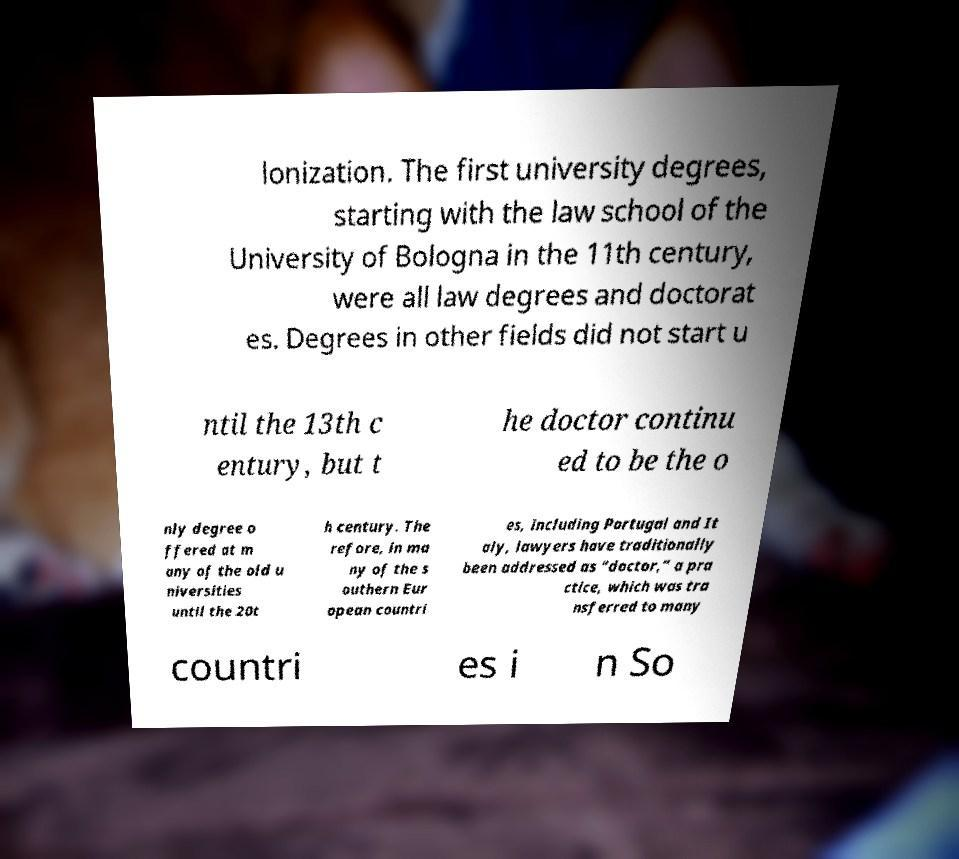Please read and relay the text visible in this image. What does it say? lonization. The first university degrees, starting with the law school of the University of Bologna in the 11th century, were all law degrees and doctorat es. Degrees in other fields did not start u ntil the 13th c entury, but t he doctor continu ed to be the o nly degree o ffered at m any of the old u niversities until the 20t h century. The refore, in ma ny of the s outhern Eur opean countri es, including Portugal and It aly, lawyers have traditionally been addressed as “doctor,” a pra ctice, which was tra nsferred to many countri es i n So 